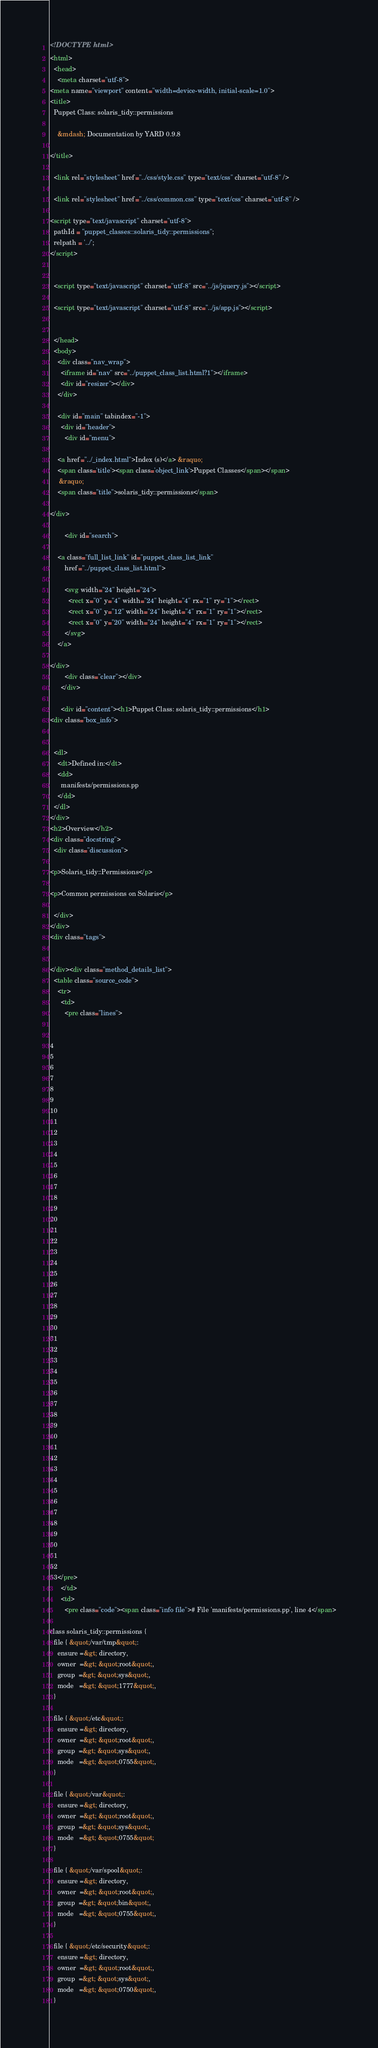<code> <loc_0><loc_0><loc_500><loc_500><_HTML_><!DOCTYPE html>
<html>
  <head>
    <meta charset="utf-8">
<meta name="viewport" content="width=device-width, initial-scale=1.0">
<title>
  Puppet Class: solaris_tidy::permissions
  
    &mdash; Documentation by YARD 0.9.8
  
</title>

  <link rel="stylesheet" href="../css/style.css" type="text/css" charset="utf-8" />

  <link rel="stylesheet" href="../css/common.css" type="text/css" charset="utf-8" />

<script type="text/javascript" charset="utf-8">
  pathId = "puppet_classes::solaris_tidy::permissions";
  relpath = '../';
</script>


  <script type="text/javascript" charset="utf-8" src="../js/jquery.js"></script>

  <script type="text/javascript" charset="utf-8" src="../js/app.js"></script>


  </head>
  <body>
    <div class="nav_wrap">
      <iframe id="nav" src="../puppet_class_list.html?1"></iframe>
      <div id="resizer"></div>
    </div>

    <div id="main" tabindex="-1">
      <div id="header">
        <div id="menu">
  
    <a href="../_index.html">Index (s)</a> &raquo;
    <span class='title'><span class='object_link'>Puppet Classes</span></span>
     &raquo; 
    <span class="title">solaris_tidy::permissions</span>
  
</div>

        <div id="search">
  
    <a class="full_list_link" id="puppet_class_list_link"
        href="../puppet_class_list.html">

        <svg width="24" height="24">
          <rect x="0" y="4" width="24" height="4" rx="1" ry="1"></rect>
          <rect x="0" y="12" width="24" height="4" rx="1" ry="1"></rect>
          <rect x="0" y="20" width="24" height="4" rx="1" ry="1"></rect>
        </svg>
    </a>
  
</div>
        <div class="clear"></div>
      </div>

      <div id="content"><h1>Puppet Class: solaris_tidy::permissions</h1>
<div class="box_info">
  
  
  <dl>
    <dt>Defined in:</dt>
    <dd>
      manifests/permissions.pp
    </dd>
  </dl>
</div>
<h2>Overview</h2>
<div class="docstring">
  <div class="discussion">
    
<p>Solaris_tidy::Permissions</p>

<p>Common permissions on Solaris</p>

  </div>
</div>
<div class="tags">
  

</div><div class="method_details_list">
  <table class="source_code">
    <tr>
      <td>
        <pre class="lines">


4
5
6
7
8
9
10
11
12
13
14
15
16
17
18
19
20
21
22
23
24
25
26
27
28
29
30
31
32
33
34
35
36
37
38
39
40
41
42
43
44
45
46
47
48
49
50
51
52
53</pre>
      </td>
      <td>
        <pre class="code"><span class="info file"># File 'manifests/permissions.pp', line 4</span>

class solaris_tidy::permissions {
  file { &quot;/var/tmp&quot;:
    ensure =&gt; directory,
    owner  =&gt; &quot;root&quot;,
    group  =&gt; &quot;sys&quot;,
    mode   =&gt; &quot;1777&quot;,
  }

  file { &quot;/etc&quot;:
    ensure =&gt; directory,
    owner  =&gt; &quot;root&quot;,
    group  =&gt; &quot;sys&quot;,
    mode   =&gt; &quot;0755&quot;,
  }

  file { &quot;/var&quot;:
    ensure =&gt; directory,
    owner  =&gt; &quot;root&quot;,
    group  =&gt; &quot;sys&quot;,
    mode   =&gt; &quot;0755&quot;
  }

  file { &quot;/var/spool&quot;:
    ensure =&gt; directory,
    owner  =&gt; &quot;root&quot;,
    group  =&gt; &quot;bin&quot;,
    mode   =&gt; &quot;0755&quot;,
  }

  file { &quot;/etc/security&quot;:
    ensure =&gt; directory,
    owner  =&gt; &quot;root&quot;,
    group  =&gt; &quot;sys&quot;,
    mode   =&gt; &quot;0750&quot;,
  }
</code> 